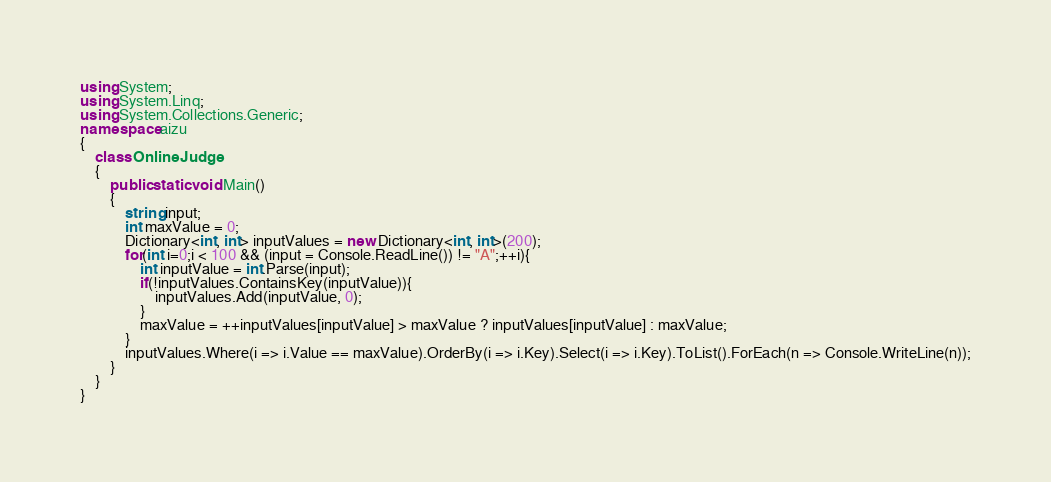<code> <loc_0><loc_0><loc_500><loc_500><_C#_>using System;
using System.Linq;
using System.Collections.Generic;
namespace aizu
{
    class OnlineJudge
    {
        public static void Main()
        {
			string input;
			int maxValue = 0;
			Dictionary<int, int> inputValues = new Dictionary<int, int>(200);
			for(int i=0;i < 100 && (input = Console.ReadLine()) != "A";++i){
				int inputValue = int.Parse(input);
				if(!inputValues.ContainsKey(inputValue)){
					inputValues.Add(inputValue, 0);
				}
				maxValue = ++inputValues[inputValue] > maxValue ? inputValues[inputValue] : maxValue;
			}
			inputValues.Where(i => i.Value == maxValue).OrderBy(i => i.Key).Select(i => i.Key).ToList().ForEach(n => Console.WriteLine(n));
        }
    }
}</code> 